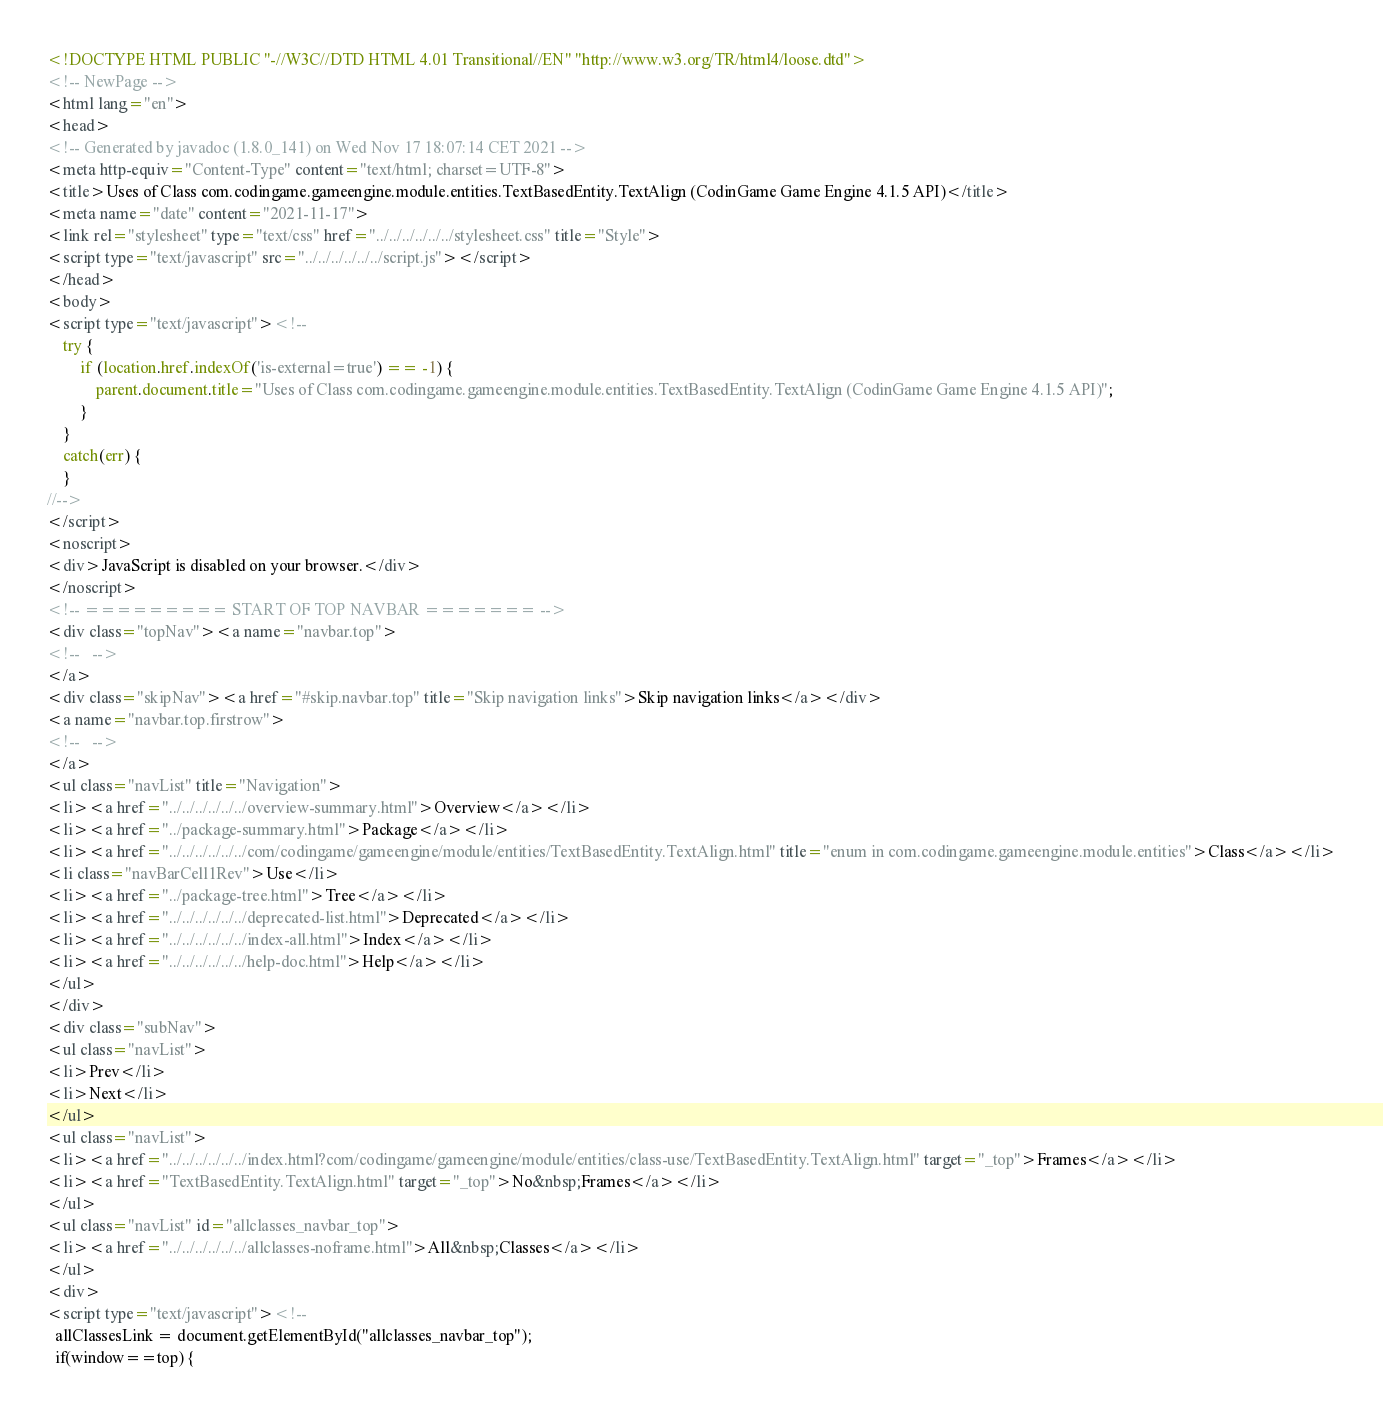Convert code to text. <code><loc_0><loc_0><loc_500><loc_500><_HTML_><!DOCTYPE HTML PUBLIC "-//W3C//DTD HTML 4.01 Transitional//EN" "http://www.w3.org/TR/html4/loose.dtd">
<!-- NewPage -->
<html lang="en">
<head>
<!-- Generated by javadoc (1.8.0_141) on Wed Nov 17 18:07:14 CET 2021 -->
<meta http-equiv="Content-Type" content="text/html; charset=UTF-8">
<title>Uses of Class com.codingame.gameengine.module.entities.TextBasedEntity.TextAlign (CodinGame Game Engine 4.1.5 API)</title>
<meta name="date" content="2021-11-17">
<link rel="stylesheet" type="text/css" href="../../../../../../stylesheet.css" title="Style">
<script type="text/javascript" src="../../../../../../script.js"></script>
</head>
<body>
<script type="text/javascript"><!--
    try {
        if (location.href.indexOf('is-external=true') == -1) {
            parent.document.title="Uses of Class com.codingame.gameengine.module.entities.TextBasedEntity.TextAlign (CodinGame Game Engine 4.1.5 API)";
        }
    }
    catch(err) {
    }
//-->
</script>
<noscript>
<div>JavaScript is disabled on your browser.</div>
</noscript>
<!-- ========= START OF TOP NAVBAR ======= -->
<div class="topNav"><a name="navbar.top">
<!--   -->
</a>
<div class="skipNav"><a href="#skip.navbar.top" title="Skip navigation links">Skip navigation links</a></div>
<a name="navbar.top.firstrow">
<!--   -->
</a>
<ul class="navList" title="Navigation">
<li><a href="../../../../../../overview-summary.html">Overview</a></li>
<li><a href="../package-summary.html">Package</a></li>
<li><a href="../../../../../../com/codingame/gameengine/module/entities/TextBasedEntity.TextAlign.html" title="enum in com.codingame.gameengine.module.entities">Class</a></li>
<li class="navBarCell1Rev">Use</li>
<li><a href="../package-tree.html">Tree</a></li>
<li><a href="../../../../../../deprecated-list.html">Deprecated</a></li>
<li><a href="../../../../../../index-all.html">Index</a></li>
<li><a href="../../../../../../help-doc.html">Help</a></li>
</ul>
</div>
<div class="subNav">
<ul class="navList">
<li>Prev</li>
<li>Next</li>
</ul>
<ul class="navList">
<li><a href="../../../../../../index.html?com/codingame/gameengine/module/entities/class-use/TextBasedEntity.TextAlign.html" target="_top">Frames</a></li>
<li><a href="TextBasedEntity.TextAlign.html" target="_top">No&nbsp;Frames</a></li>
</ul>
<ul class="navList" id="allclasses_navbar_top">
<li><a href="../../../../../../allclasses-noframe.html">All&nbsp;Classes</a></li>
</ul>
<div>
<script type="text/javascript"><!--
  allClassesLink = document.getElementById("allclasses_navbar_top");
  if(window==top) {</code> 